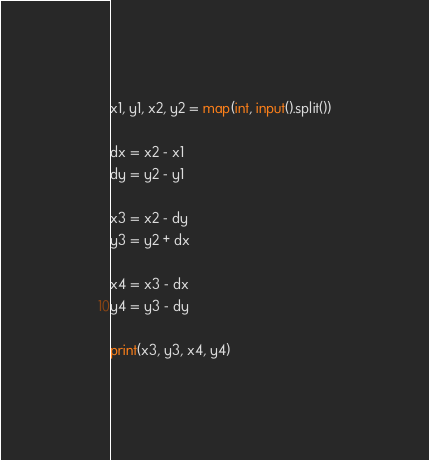Convert code to text. <code><loc_0><loc_0><loc_500><loc_500><_Python_>x1, y1, x2, y2 = map(int, input().split())

dx = x2 - x1
dy = y2 - y1

x3 = x2 - dy
y3 = y2 + dx

x4 = x3 - dx
y4 = y3 - dy

print(x3, y3, x4, y4)
</code> 